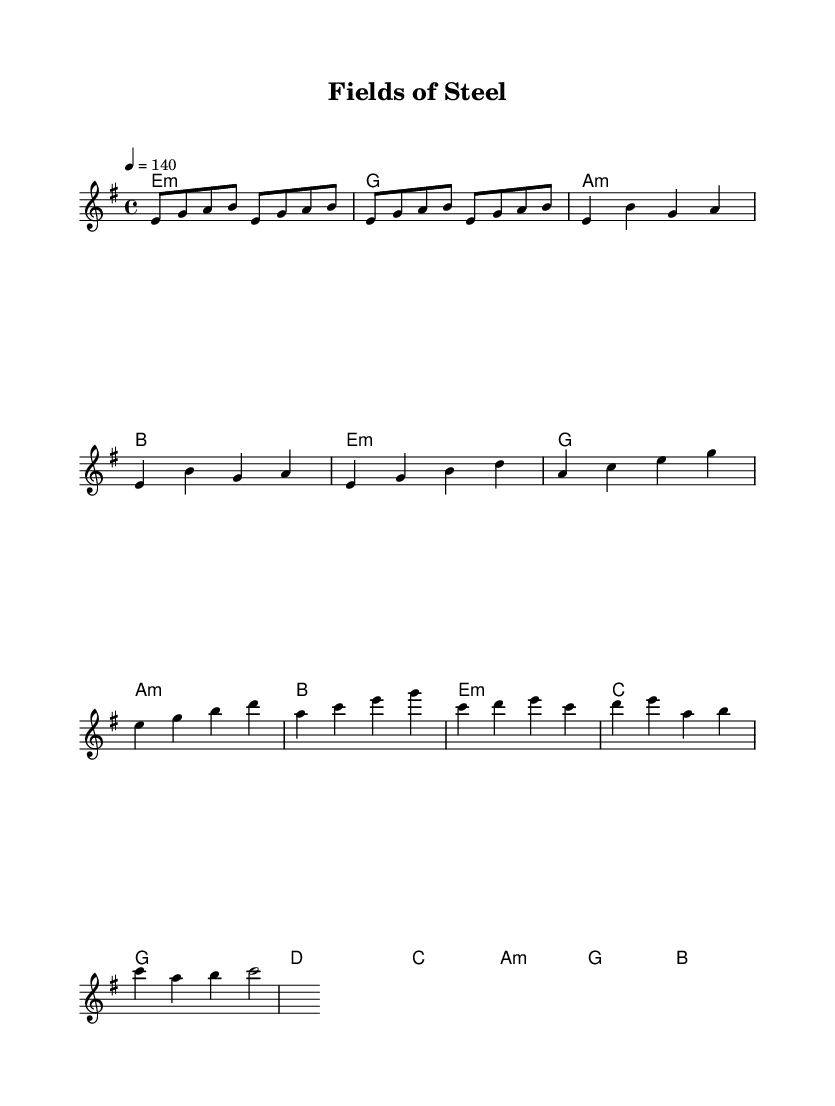What is the key signature of this music? The key signature is E minor, which is identified by one sharp (F#). This can be inferred from the indicated key at the beginning of the piece.
Answer: E minor What is the time signature? The time signature is 4/4, which means there are four beats in a measure and the quarter note gets one beat. This is explicitly stated in the score.
Answer: 4/4 What is the tempo marking? The tempo marking is quarter note equals 140 beats per minute, indicated at the beginning of the score for understanding the pace of the music.
Answer: 140 How many measures are in the chorus section? The chorus consists of four measures as can be counted in the melodic line under the 'Chorus' label in the sheet music.
Answer: 4 What is the last chord in the bridge? The last chord in the bridge section is B major, noted at the end of that segment of the harmony part.
Answer: B Which voice sings the melody? The melody is performed by the "melody" voice, as identified by the label placed in the score indicating the specific part.
Answer: melody What is the primary thematic focus of this piece? The thematic focus is on agricultural traditions and rural pride, inferred from the title "Fields of Steel" and the overall farm-related imagery within the lyrics and music structure common in metal anthems.
Answer: agricultural traditions 